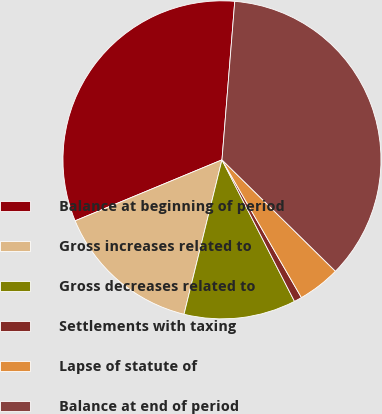<chart> <loc_0><loc_0><loc_500><loc_500><pie_chart><fcel>Balance at beginning of period<fcel>Gross increases related to<fcel>Gross decreases related to<fcel>Settlements with taxing<fcel>Lapse of statute of<fcel>Balance at end of period<nl><fcel>32.54%<fcel>14.9%<fcel>11.37%<fcel>0.79%<fcel>4.32%<fcel>36.07%<nl></chart> 